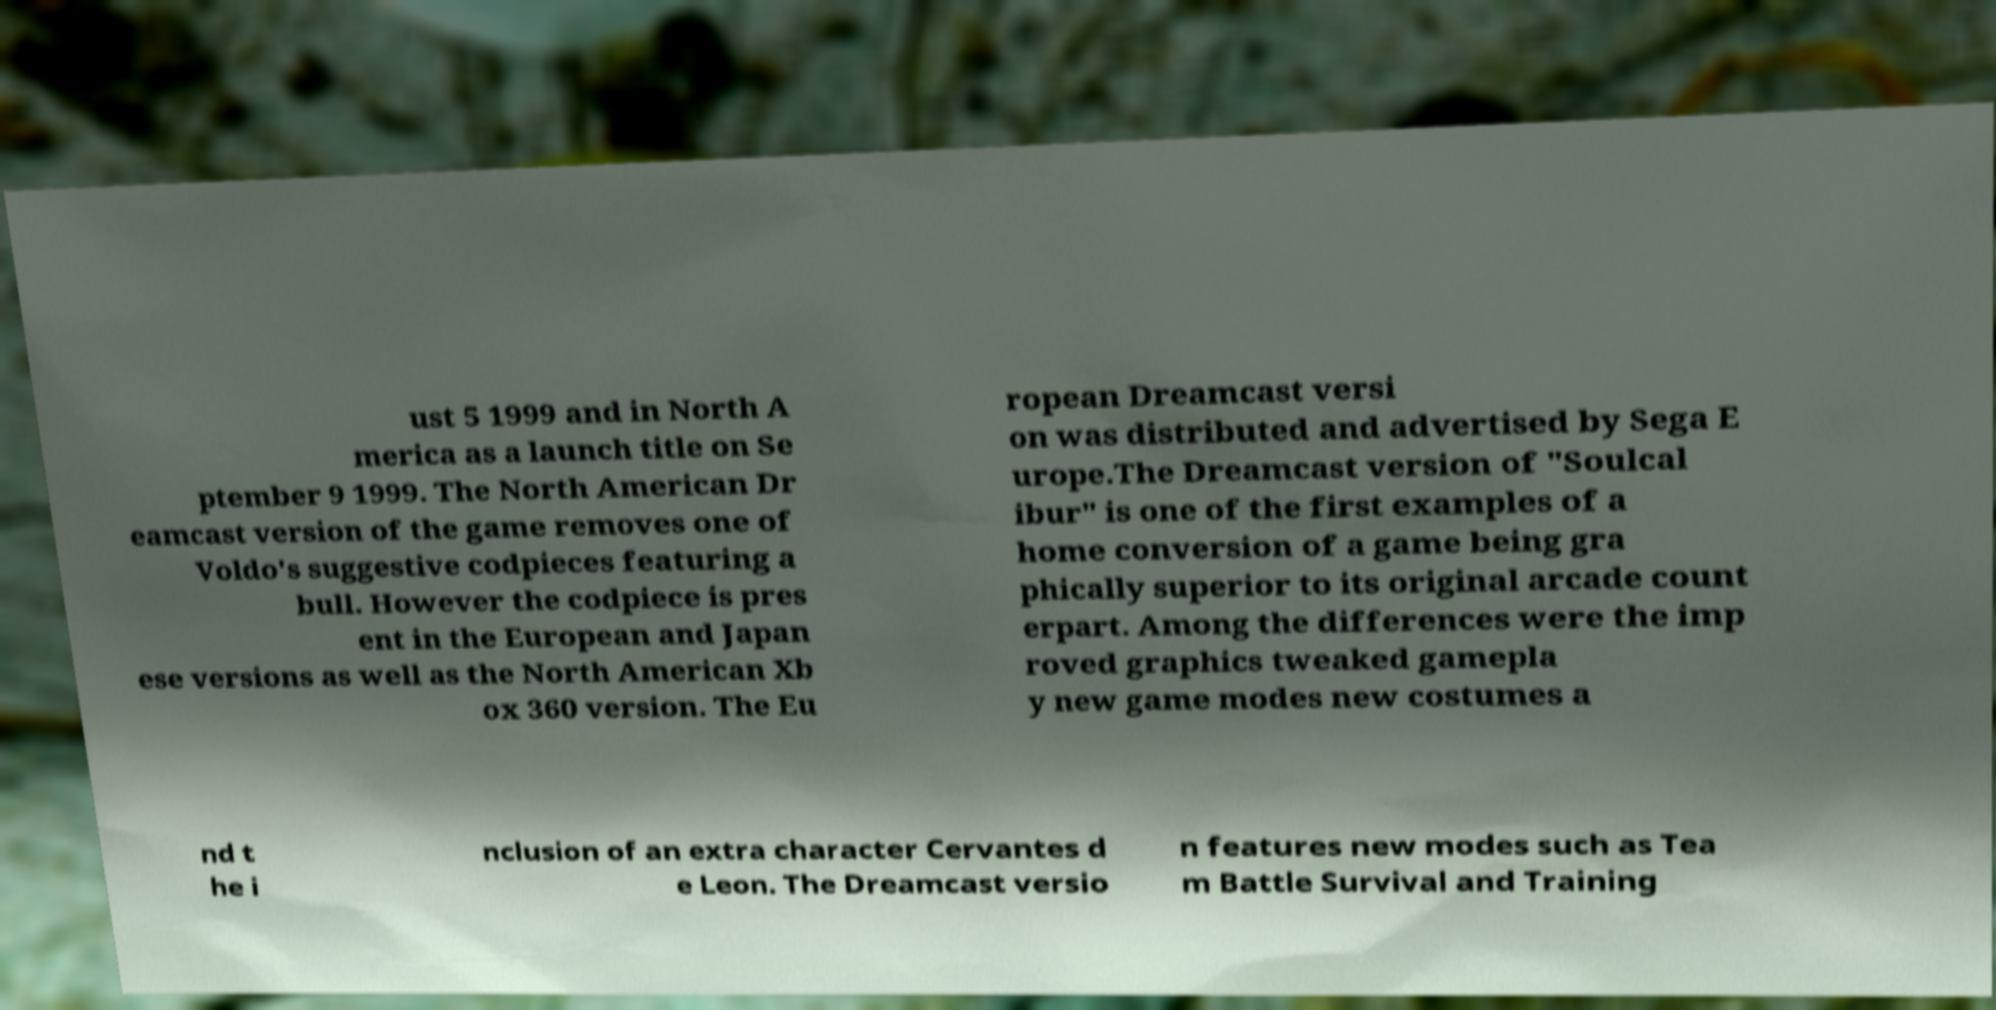Can you accurately transcribe the text from the provided image for me? ust 5 1999 and in North A merica as a launch title on Se ptember 9 1999. The North American Dr eamcast version of the game removes one of Voldo's suggestive codpieces featuring a bull. However the codpiece is pres ent in the European and Japan ese versions as well as the North American Xb ox 360 version. The Eu ropean Dreamcast versi on was distributed and advertised by Sega E urope.The Dreamcast version of "Soulcal ibur" is one of the first examples of a home conversion of a game being gra phically superior to its original arcade count erpart. Among the differences were the imp roved graphics tweaked gamepla y new game modes new costumes a nd t he i nclusion of an extra character Cervantes d e Leon. The Dreamcast versio n features new modes such as Tea m Battle Survival and Training 